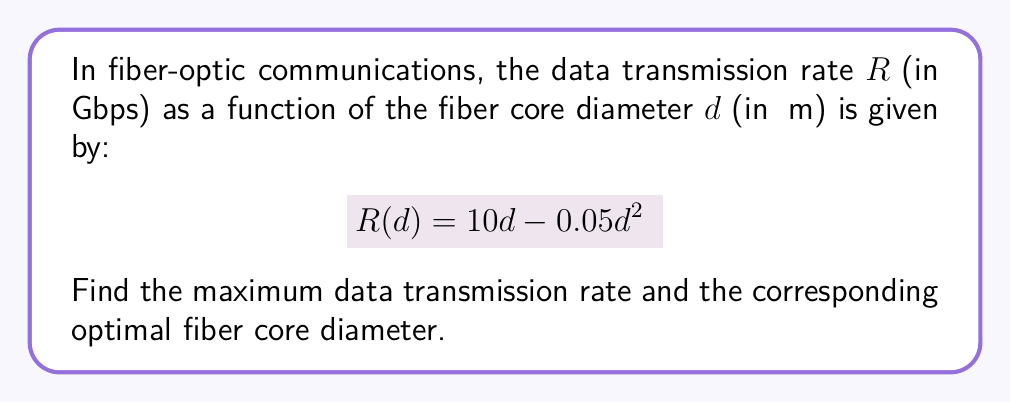Help me with this question. To find the maximum data transmission rate and the optimal fiber core diameter, we need to follow these steps:

1) First, we need to find the derivative of $R(d)$ with respect to $d$:
   $$R'(d) = 10 - 0.1d$$

2) To find the maximum, we set $R'(d) = 0$ and solve for $d$:
   $$10 - 0.1d = 0$$
   $$0.1d = 10$$
   $$d = 100$$

3) This critical point $d = 100$ μm gives us the optimal fiber core diameter.

4) To confirm this is a maximum (not a minimum), we can check the second derivative:
   $$R''(d) = -0.1$$
   Since $R''(d)$ is negative, we confirm that $d = 100$ μm gives a maximum.

5) To find the maximum data transmission rate, we substitute $d = 100$ into the original function:
   $$R(100) = 10(100) - 0.05(100)^2$$
   $$= 1000 - 500 = 500$$

Therefore, the maximum data transmission rate is 500 Gbps, occurring when the fiber core diameter is 100 μm.
Answer: Maximum rate: 500 Gbps; Optimal diameter: 100 μm 